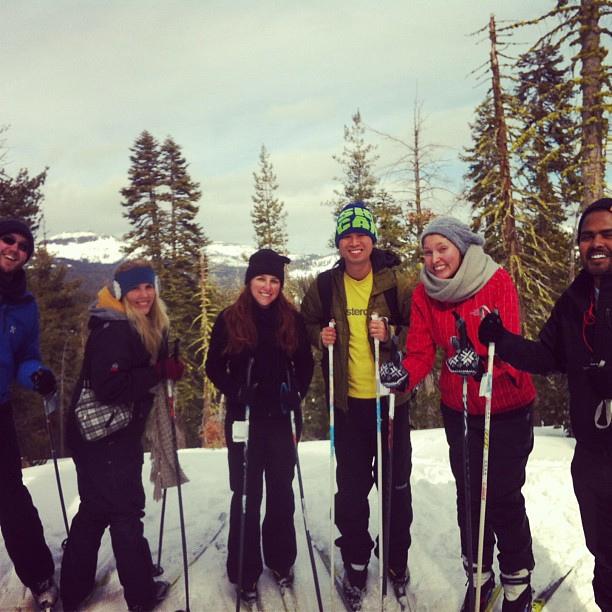Do the clouds look like snow clouds?
Be succinct. Yes. What color is this woman's jacket?
Keep it brief. Red. Is it cold?
Keep it brief. Yes. How many ladies are there?
Be succinct. 3. Do all of these people have ski poles?
Concise answer only. Yes. Are the skiers wearing goggles?
Be succinct. No. Do they use the same equipment?
Be succinct. Yes. 